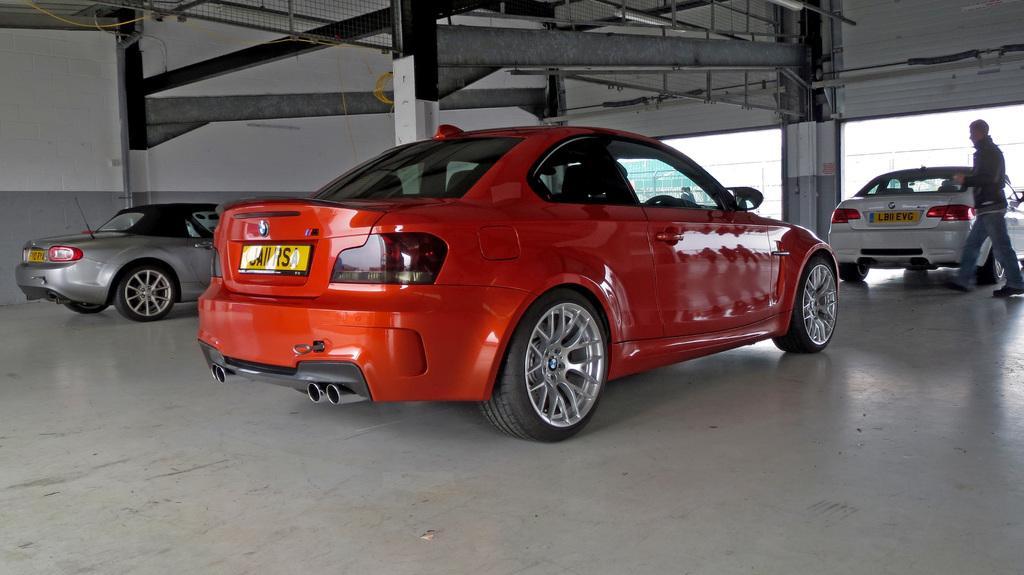Describe this image in one or two sentences. In this picture we can see some vehicles parked on the path and a person is walking. Behind the vehicles there are pillars, wall and it looks like the sky. 